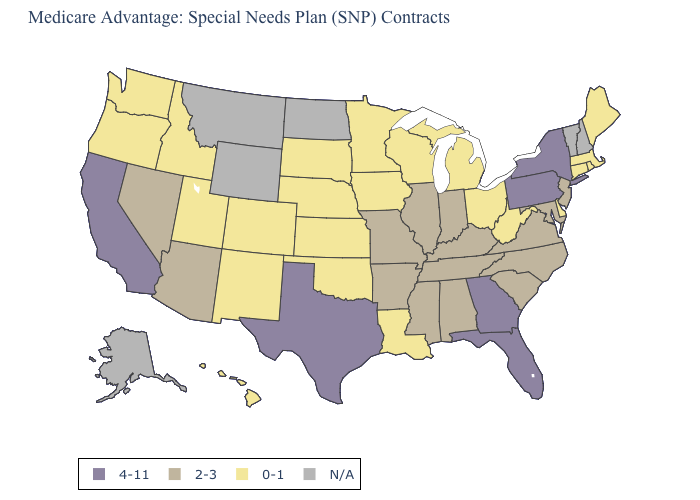Name the states that have a value in the range N/A?
Keep it brief. Alaska, Montana, North Dakota, New Hampshire, Vermont, Wyoming. Does the map have missing data?
Short answer required. Yes. Is the legend a continuous bar?
Be succinct. No. What is the value of Mississippi?
Short answer required. 2-3. Name the states that have a value in the range N/A?
Be succinct. Alaska, Montana, North Dakota, New Hampshire, Vermont, Wyoming. What is the value of Maine?
Write a very short answer. 0-1. What is the value of Oregon?
Quick response, please. 0-1. What is the value of Iowa?
Be succinct. 0-1. Does Missouri have the highest value in the MidWest?
Answer briefly. Yes. Which states have the highest value in the USA?
Concise answer only. California, Florida, Georgia, New York, Pennsylvania, Texas. Among the states that border California , which have the lowest value?
Answer briefly. Oregon. Name the states that have a value in the range 4-11?
Give a very brief answer. California, Florida, Georgia, New York, Pennsylvania, Texas. Which states have the highest value in the USA?
Quick response, please. California, Florida, Georgia, New York, Pennsylvania, Texas. Does the map have missing data?
Answer briefly. Yes. 